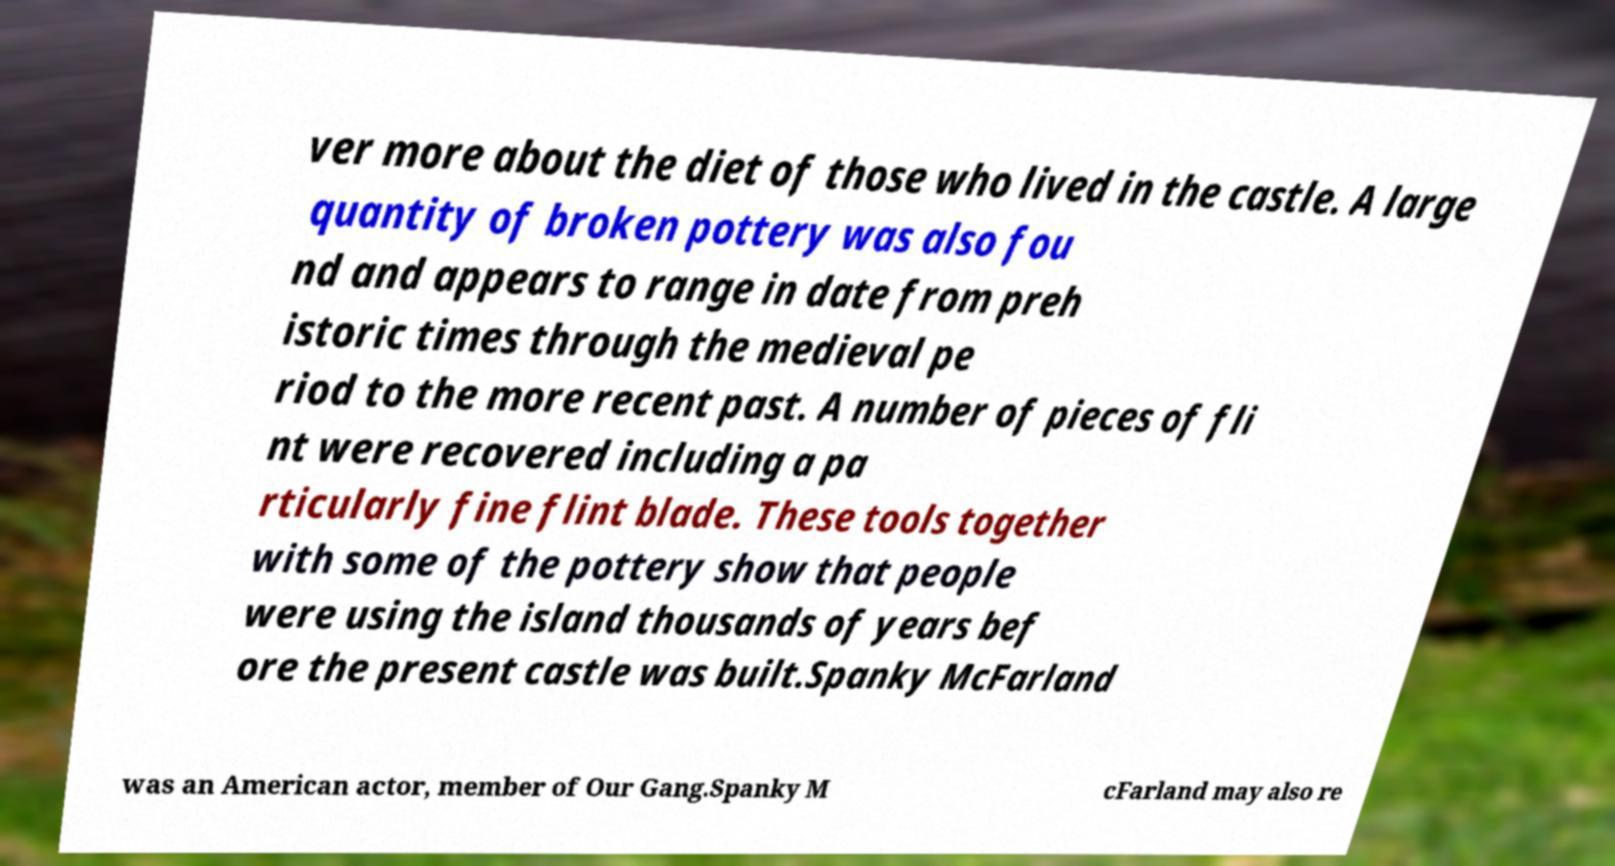Please read and relay the text visible in this image. What does it say? ver more about the diet of those who lived in the castle. A large quantity of broken pottery was also fou nd and appears to range in date from preh istoric times through the medieval pe riod to the more recent past. A number of pieces of fli nt were recovered including a pa rticularly fine flint blade. These tools together with some of the pottery show that people were using the island thousands of years bef ore the present castle was built.Spanky McFarland was an American actor, member of Our Gang.Spanky M cFarland may also re 